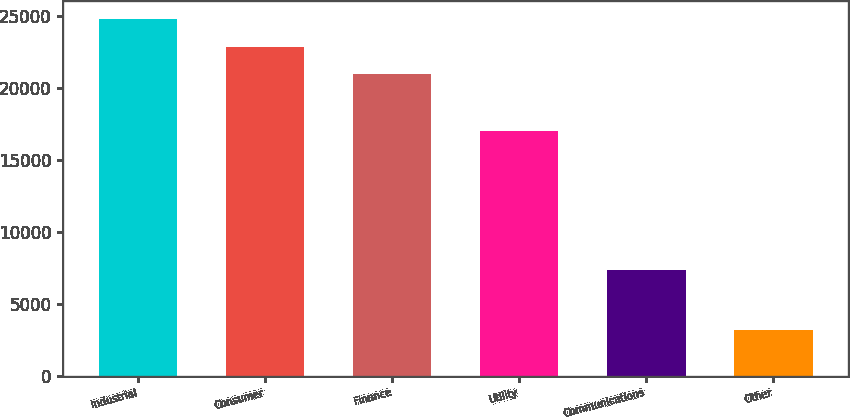Convert chart. <chart><loc_0><loc_0><loc_500><loc_500><bar_chart><fcel>Industrial<fcel>Consumer<fcel>Finance<fcel>Utility<fcel>Communications<fcel>Other<nl><fcel>24740.2<fcel>22828.6<fcel>20917<fcel>17027<fcel>7375<fcel>3198<nl></chart> 